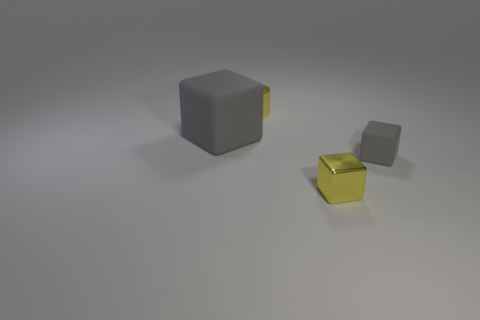There is a cube that is the same color as the tiny cylinder; what is it made of?
Provide a succinct answer. Metal. The other matte object that is the same shape as the large thing is what color?
Give a very brief answer. Gray. There is a gray object on the left side of the small shiny cube; is its shape the same as the yellow thing left of the small yellow block?
Offer a very short reply. No. There is a cylinder; is it the same size as the gray block that is to the right of the large gray thing?
Offer a very short reply. Yes. Are there more large things than tiny cyan metal cylinders?
Provide a short and direct response. Yes. Are the small yellow thing that is in front of the big gray matte thing and the gray block to the left of the yellow block made of the same material?
Offer a very short reply. No. What is the small cylinder made of?
Provide a short and direct response. Metal. Is the number of gray matte cubes that are behind the tiny cylinder greater than the number of rubber cubes?
Provide a short and direct response. No. There is a yellow thing behind the tiny thing that is in front of the tiny matte cube; what number of metal things are right of it?
Your answer should be very brief. 1. The cube that is both left of the tiny gray thing and to the right of the small yellow metal cylinder is made of what material?
Your answer should be compact. Metal. 